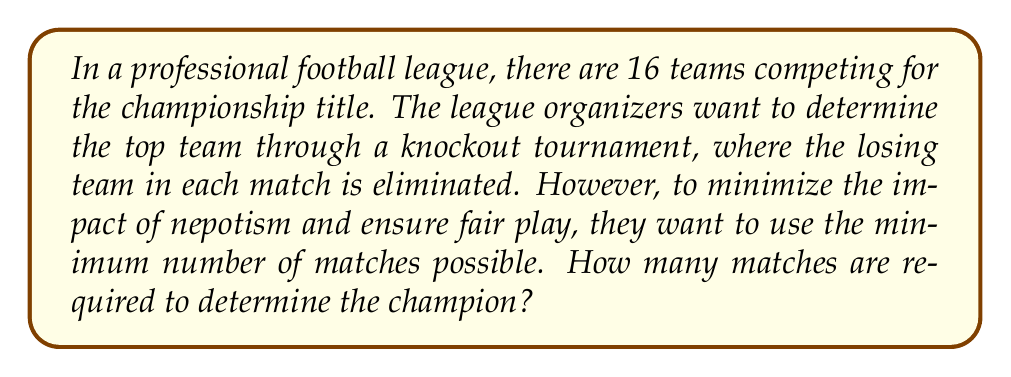Teach me how to tackle this problem. To solve this problem, we can use concepts from graph theory, specifically tournament graphs.

1) In a knockout tournament, each match eliminates one team. To find the champion, we need to eliminate all teams except one.

2) With 16 teams, we need to eliminate 15 teams (16 - 1 = 15).

3) Each match eliminates exactly one team, so the minimum number of matches needed is equal to the number of teams that need to be eliminated.

4) We can represent this mathematically:
   Let $n$ be the number of teams
   Number of matches = $n - 1$

5) In this case:
   $n = 16$
   Number of matches = $16 - 1 = 15$

6) We can verify this using the concept of a binary tree:
   - Each match can be represented as a node in a binary tree
   - The 16 teams are the leaves of this tree
   - The champion is the root of the tree
   - In a full binary tree with $n$ leaves, there are $n-1$ internal nodes

7) The structure of this tournament can be represented as follows:

[asy]
unitsize(0.5cm);
for(int i=0; i<8; ++i) {
  dot((2*i,-8));
}
for(int i=0; i<4; ++i) {
  dot((4*i+1,-6));
  draw((4*i,-8)--(4*i+1,-6)--(4*i+2,-8));
}
for(int i=0; i<2; ++i) {
  dot((8*i+3,-4));
  draw((8*i+1,-6)--(8*i+3,-4)--(8*i+5,-6));
}
dot((7,-2));
draw((3,-4)--(7,-2)--(11,-4));
dot((7,0));
draw((7,-2)--(7,0));
label("Champion",(7,1),N);
[/asy]

This tree has 15 internal nodes (matches), confirming our calculation.
Answer: The minimum number of matches required to determine the champion among 16 teams is 15. 